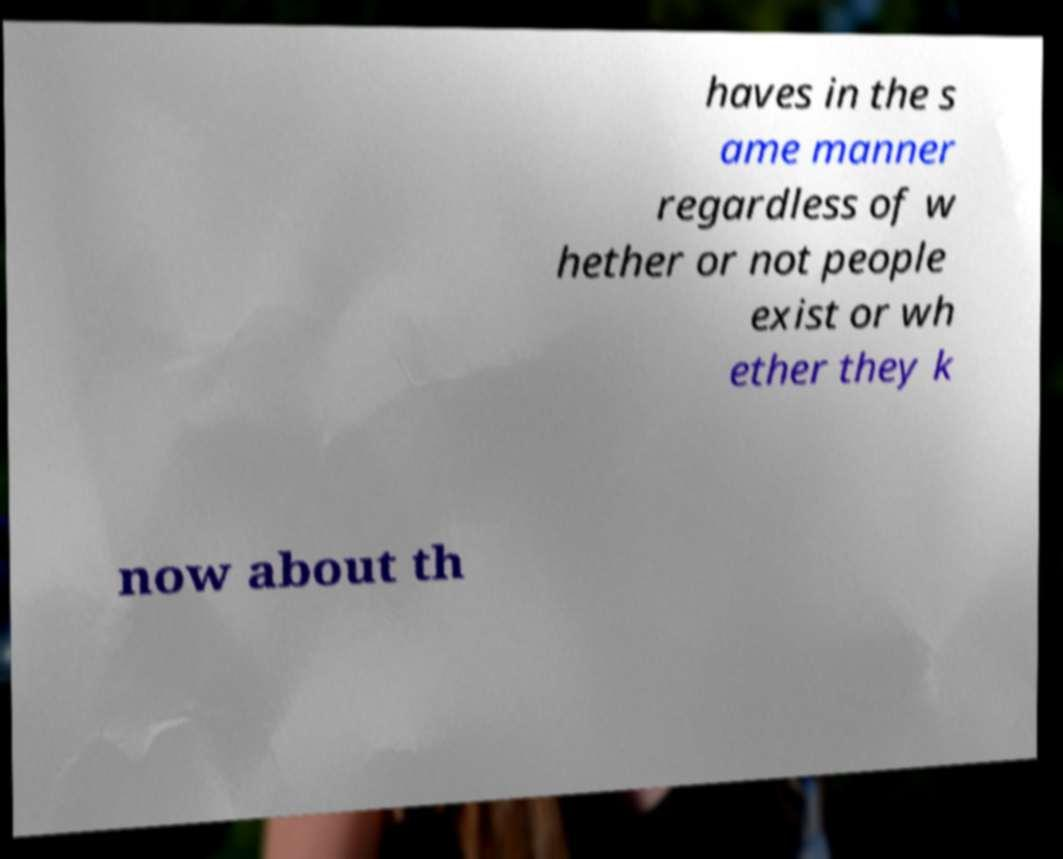What messages or text are displayed in this image? I need them in a readable, typed format. haves in the s ame manner regardless of w hether or not people exist or wh ether they k now about th 